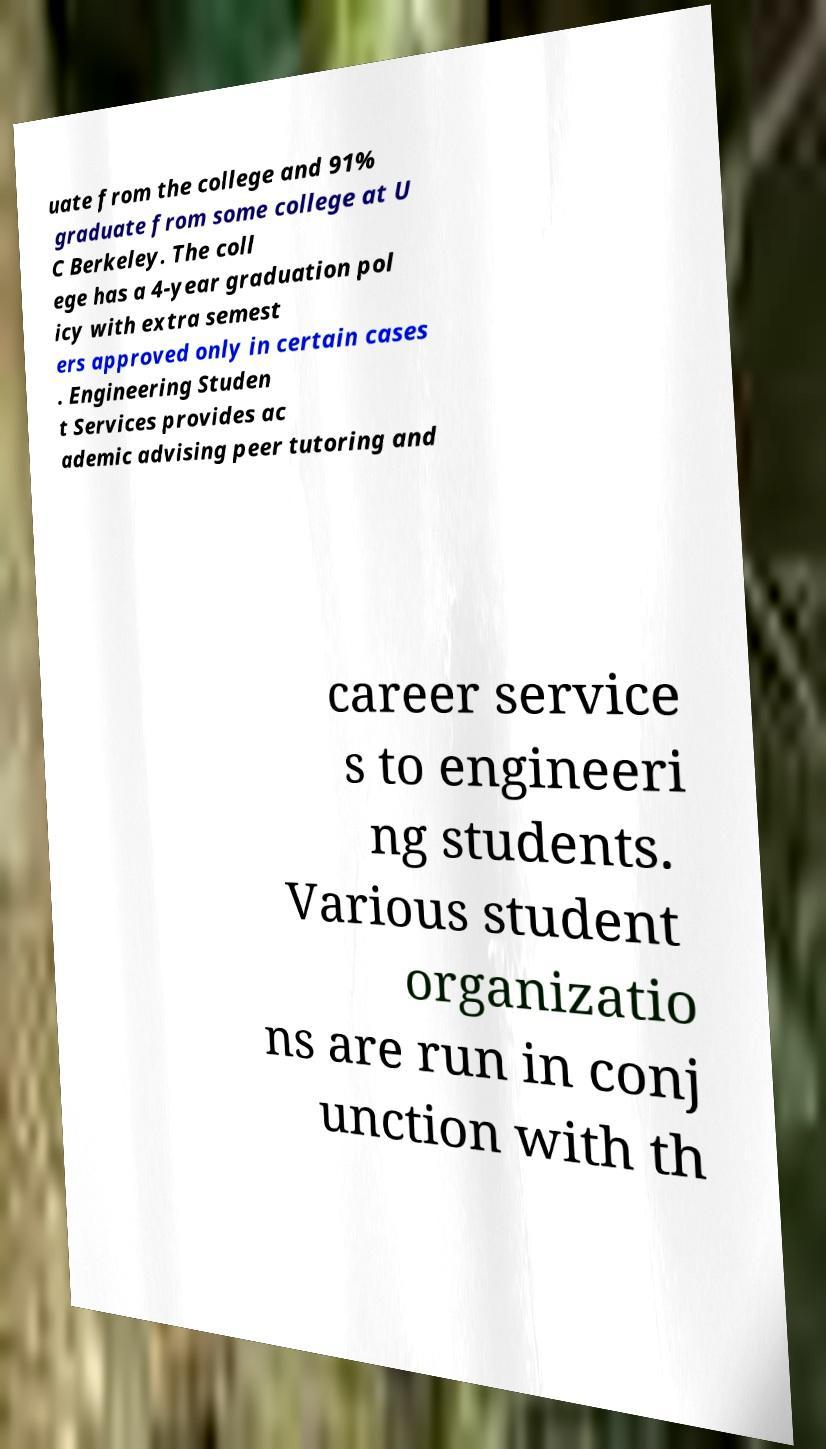Could you extract and type out the text from this image? uate from the college and 91% graduate from some college at U C Berkeley. The coll ege has a 4-year graduation pol icy with extra semest ers approved only in certain cases . Engineering Studen t Services provides ac ademic advising peer tutoring and career service s to engineeri ng students. Various student organizatio ns are run in conj unction with th 